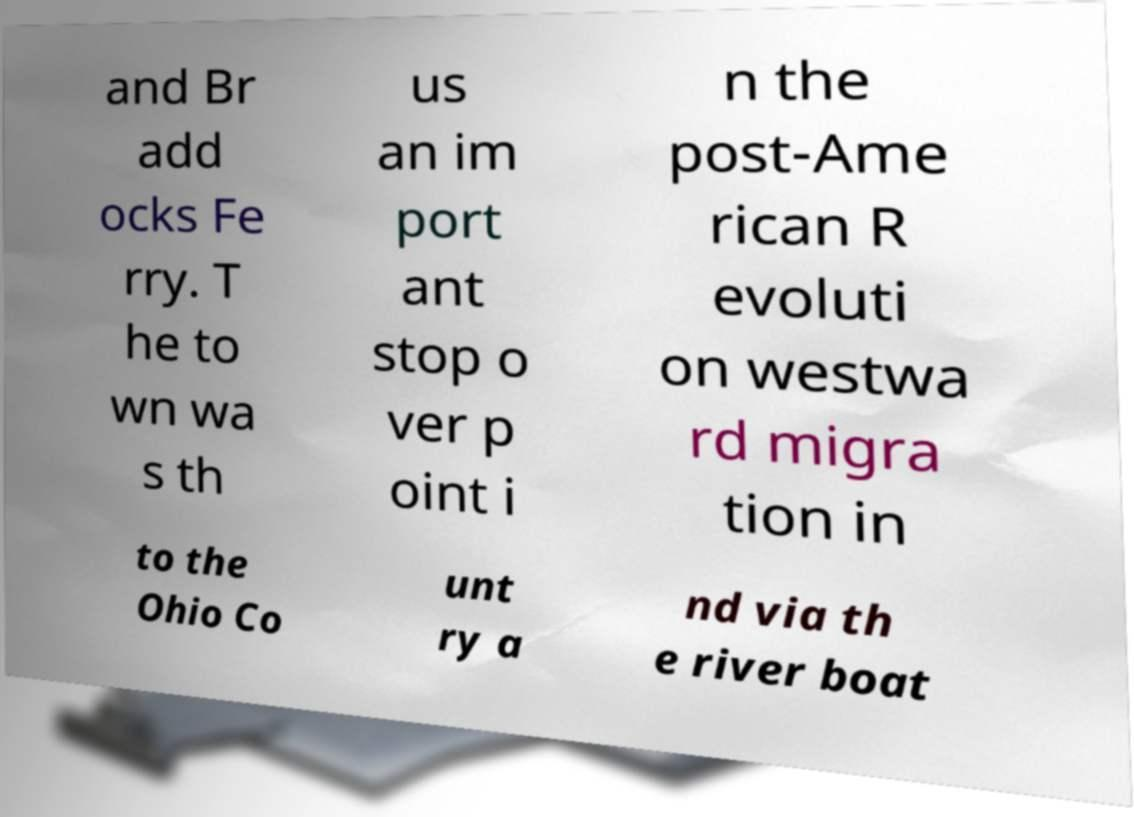For documentation purposes, I need the text within this image transcribed. Could you provide that? and Br add ocks Fe rry. T he to wn wa s th us an im port ant stop o ver p oint i n the post-Ame rican R evoluti on westwa rd migra tion in to the Ohio Co unt ry a nd via th e river boat 